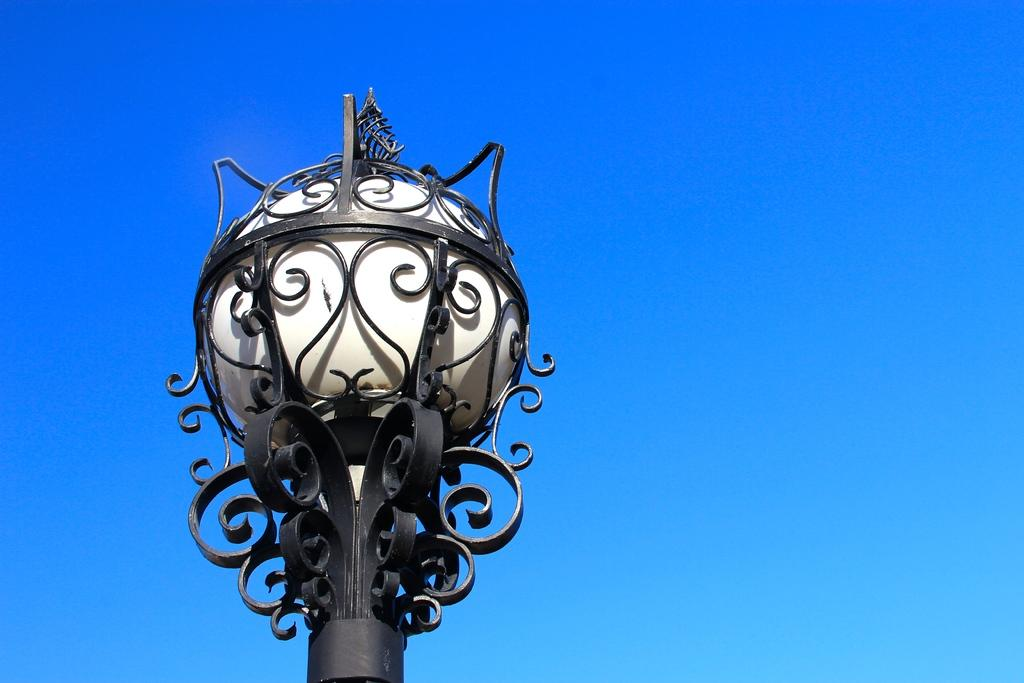What object can be seen in the image that provides light? There is a street lamp in the image that provides light. What color is the background of the image? The background of the image is blue. Can you hear the kitty laughing in the image? There is no kitty or laughter present in the image. 